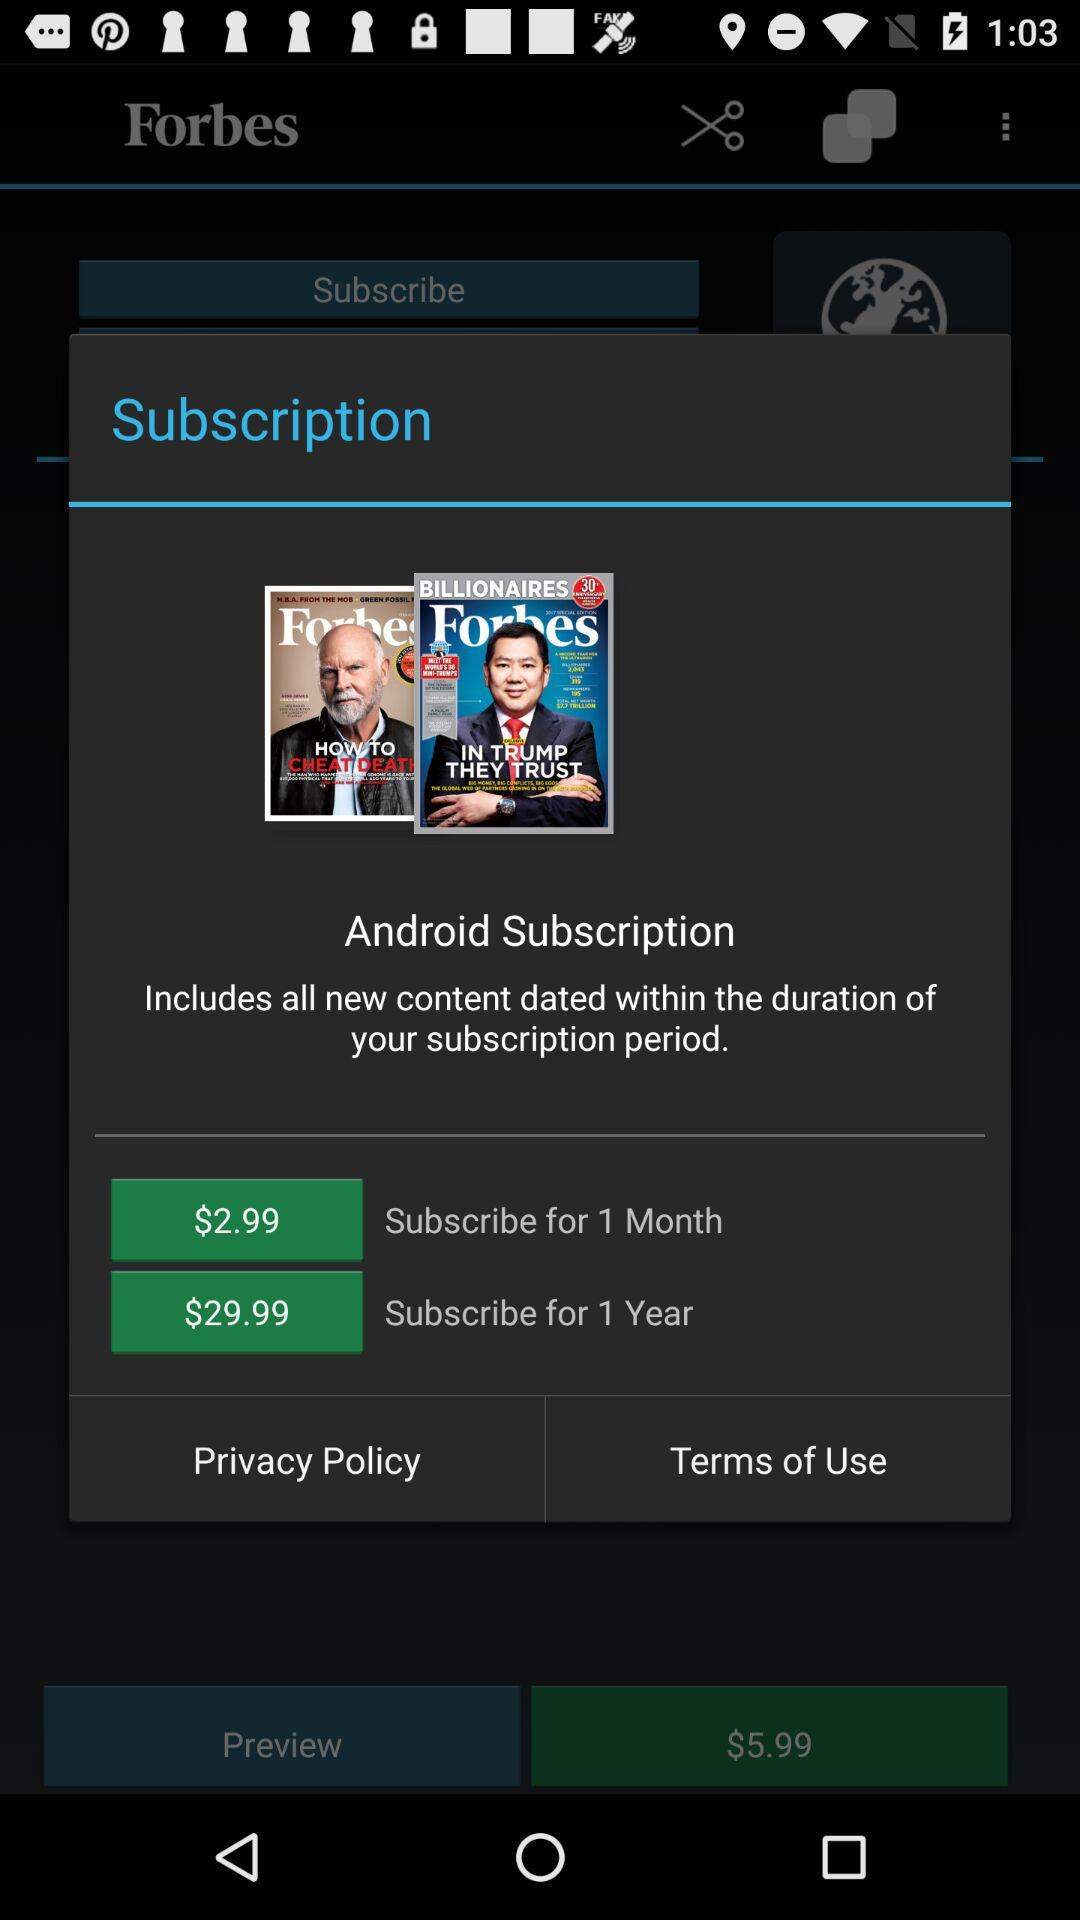What is the price of the one-month subscription? The price of the one-month subscription is $2.99. 